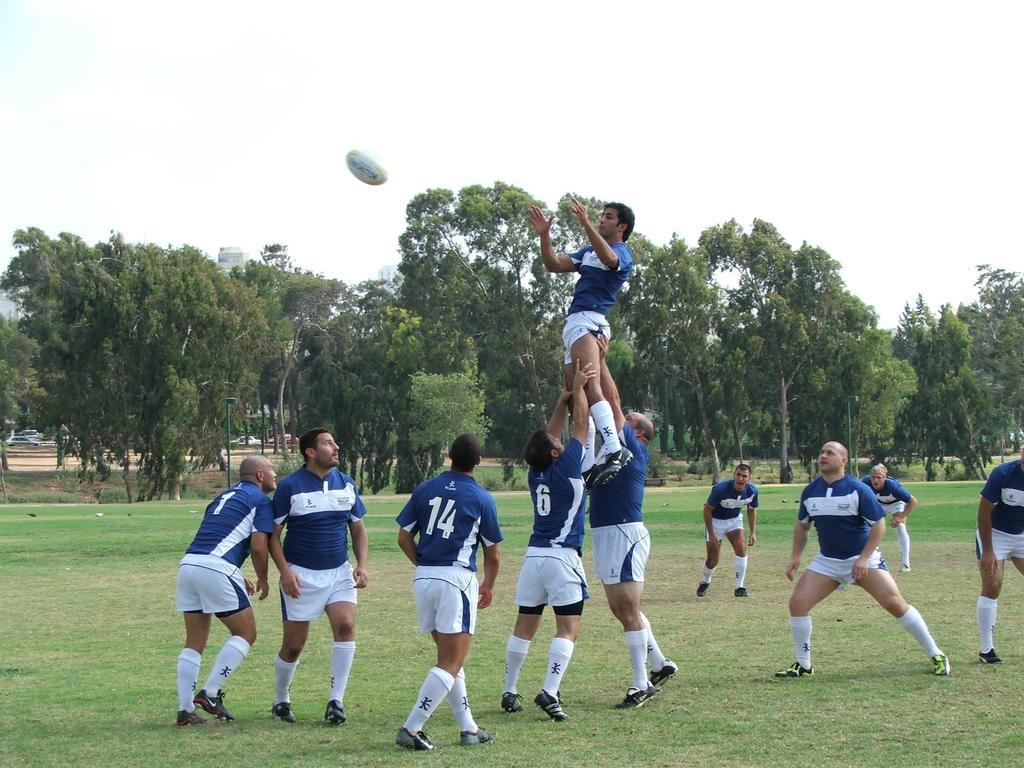<image>
Share a concise interpretation of the image provided. A group of rugby players sportin the numbers 14, 6 and 1 among others. 